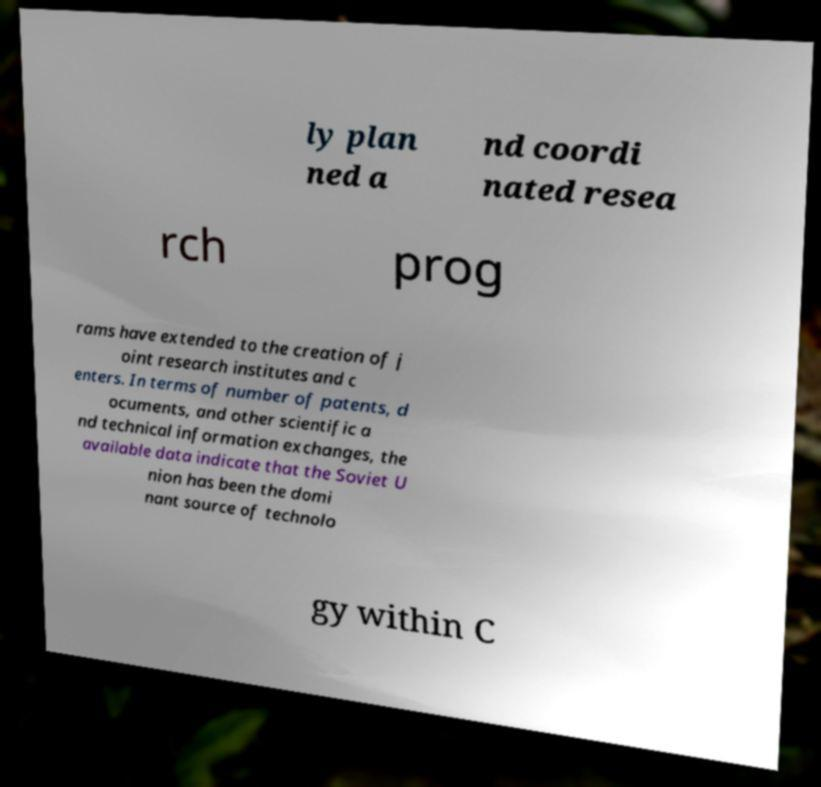Please read and relay the text visible in this image. What does it say? ly plan ned a nd coordi nated resea rch prog rams have extended to the creation of j oint research institutes and c enters. In terms of number of patents, d ocuments, and other scientific a nd technical information exchanges, the available data indicate that the Soviet U nion has been the domi nant source of technolo gy within C 